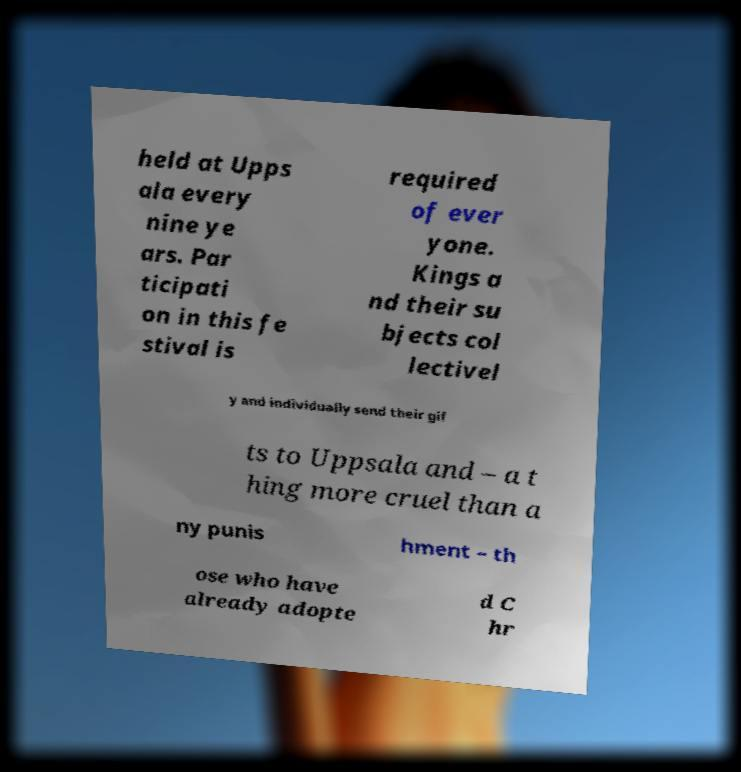Can you accurately transcribe the text from the provided image for me? held at Upps ala every nine ye ars. Par ticipati on in this fe stival is required of ever yone. Kings a nd their su bjects col lectivel y and individually send their gif ts to Uppsala and – a t hing more cruel than a ny punis hment – th ose who have already adopte d C hr 